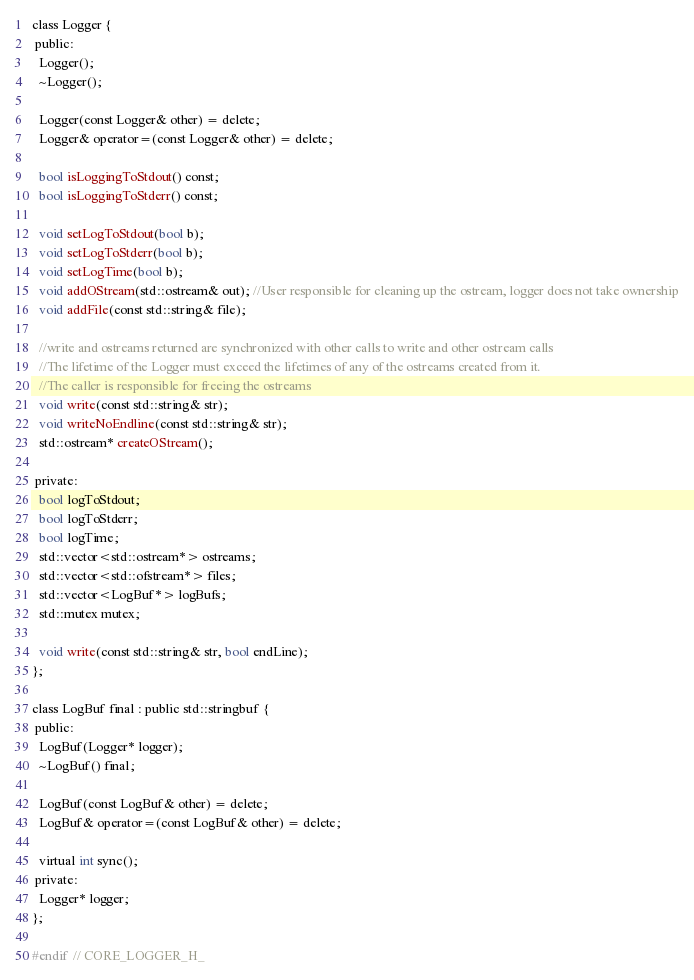Convert code to text. <code><loc_0><loc_0><loc_500><loc_500><_C_>class Logger {
 public:
  Logger();
  ~Logger();

  Logger(const Logger& other) = delete;
  Logger& operator=(const Logger& other) = delete;

  bool isLoggingToStdout() const;
  bool isLoggingToStderr() const;

  void setLogToStdout(bool b);
  void setLogToStderr(bool b);
  void setLogTime(bool b);
  void addOStream(std::ostream& out); //User responsible for cleaning up the ostream, logger does not take ownership
  void addFile(const std::string& file);

  //write and ostreams returned are synchronized with other calls to write and other ostream calls
  //The lifetime of the Logger must exceed the lifetimes of any of the ostreams created from it.
  //The caller is responsible for freeing the ostreams
  void write(const std::string& str);
  void writeNoEndline(const std::string& str);
  std::ostream* createOStream();

 private:
  bool logToStdout;
  bool logToStderr;
  bool logTime;
  std::vector<std::ostream*> ostreams;
  std::vector<std::ofstream*> files;
  std::vector<LogBuf*> logBufs;
  std::mutex mutex;

  void write(const std::string& str, bool endLine);
};

class LogBuf final : public std::stringbuf {
 public:
  LogBuf(Logger* logger);
  ~LogBuf() final;

  LogBuf(const LogBuf& other) = delete;
  LogBuf& operator=(const LogBuf& other) = delete;

  virtual int sync();
 private:
  Logger* logger;
};

#endif  // CORE_LOGGER_H_
</code> 